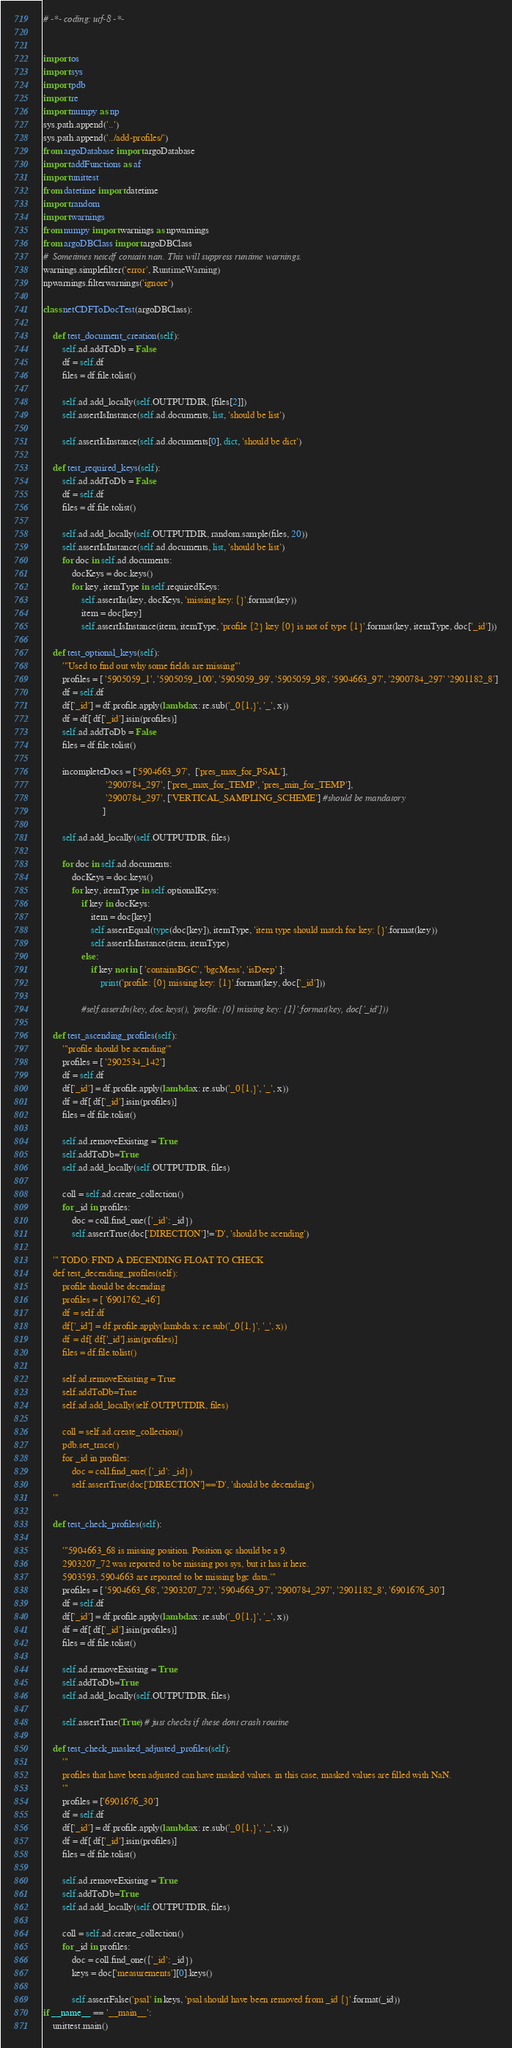Convert code to text. <code><loc_0><loc_0><loc_500><loc_500><_Python_># -*- coding: utf-8 -*-


import os
import sys
import pdb
import re
import numpy as np
sys.path.append('..')
sys.path.append('../add-profiles/')
from argoDatabase import argoDatabase
import addFunctions as af
import unittest
from datetime import datetime
import random
import warnings
from numpy import warnings as npwarnings
from argoDBClass import argoDBClass
#  Sometimes netcdf contain nan. This will suppress runtime warnings.
warnings.simplefilter('error', RuntimeWarning)
npwarnings.filterwarnings('ignore')

class netCDFToDocTest(argoDBClass):
    
    def test_document_creation(self):
        self.ad.addToDb = False
        df = self.df
        files = df.file.tolist()

        self.ad.add_locally(self.OUTPUTDIR, [files[2]])
        self.assertIsInstance(self.ad.documents, list, 'should be list')

        self.assertIsInstance(self.ad.documents[0], dict, 'should be dict')
        
    def test_required_keys(self):
        self.ad.addToDb = False
        df = self.df
        files = df.file.tolist()

        self.ad.add_locally(self.OUTPUTDIR, random.sample(files, 20))
        self.assertIsInstance(self.ad.documents, list, 'should be list')
        for doc in self.ad.documents:
            docKeys = doc.keys()
            for key, itemType in self.requiredKeys:
                self.assertIn(key, docKeys, 'missing key: {}'.format(key))
                item = doc[key]
                self.assertIsInstance(item, itemType, 'profile {2} key {0} is not of type {1}'.format(key, itemType, doc['_id']))

    def test_optional_keys(self):
        '''Used to find out why some fields are missing'''
        profiles = [ '5905059_1', '5905059_100', '5905059_99', '5905059_98', '5904663_97', '2900784_297' '2901182_8']
        df = self.df
        df['_id'] = df.profile.apply(lambda x: re.sub('_0{1,}', '_', x))
        df = df[ df['_id'].isin(profiles)]
        self.ad.addToDb = False
        files = df.file.tolist()
        
        incompleteDocs = ['5904663_97',  ['pres_max_for_PSAL'],
                          '2900784_297', ['pres_max_for_TEMP', 'pres_min_for_TEMP'],
                          '2900784_297', ['VERTICAL_SAMPLING_SCHEME'] #should be mandatory
                         ]
        
        self.ad.add_locally(self.OUTPUTDIR, files)

        for doc in self.ad.documents:
            docKeys = doc.keys()
            for key, itemType in self.optionalKeys:
                if key in docKeys:
                    item = doc[key]
                    self.assertEqual(type(doc[key]), itemType, 'item type should match for key: {}'.format(key))
                    self.assertIsInstance(item, itemType)
                else:
                    if key not in [ 'containsBGC', 'bgcMeas', 'isDeep' ]:
                        print('profile: {0} missing key: {1}'.format(key, doc['_id']))

                #self.assertIn(key, doc.keys(), 'profile: {0} missing key: {1}'.format(key, doc['_id']))

    def test_ascending_profiles(self):
        '''profile should be acending'''
        profiles = [ '2902534_142']
        df = self.df
        df['_id'] = df.profile.apply(lambda x: re.sub('_0{1,}', '_', x))
        df = df[ df['_id'].isin(profiles)]
        files = df.file.tolist()
        
        self.ad.removeExisting = True
        self.addToDb=True
        self.ad.add_locally(self.OUTPUTDIR, files)

        coll = self.ad.create_collection()
        for _id in profiles:
            doc = coll.find_one({'_id': _id})
            self.assertTrue(doc['DIRECTION']!='D', 'should be acending')
            
    ''' TODO: FIND A DECENDING FLOAT TO CHECK
    def test_decending_profiles(self):
        profile should be decending
        profiles = [ '6901762_46']
        df = self.df
        df['_id'] = df.profile.apply(lambda x: re.sub('_0{1,}', '_', x))
        df = df[ df['_id'].isin(profiles)]
        files = df.file.tolist()
        
        self.ad.removeExisting = True
        self.addToDb=True
        self.ad.add_locally(self.OUTPUTDIR, files)

        coll = self.ad.create_collection()
        pdb.set_trace()
        for _id in profiles:
            doc = coll.find_one({'_id': _id})
            self.assertTrue(doc['DIRECTION']=='D', 'should be decending')
    '''

    def test_check_profiles(self):
        
        '''5904663_68 is missing position. Position qc should be a 9.
        2903207_72 was reported to be missing pos sys, but it has it here.
        5903593, 5904663 are reported to be missing bgc data.'''
        profiles = [ '5904663_68', '2903207_72', '5904663_97', '2900784_297', '2901182_8', '6901676_30']
        df = self.df
        df['_id'] = df.profile.apply(lambda x: re.sub('_0{1,}', '_', x))
        df = df[ df['_id'].isin(profiles)]
        files = df.file.tolist()
        
        self.ad.removeExisting = True
        self.addToDb=True
        self.ad.add_locally(self.OUTPUTDIR, files)

        self.assertTrue(True) # just checks if these dont crash routine

    def test_check_masked_adjusted_profiles(self):
        '''
        profiles that have been adjusted can have masked values. in this case, masked values are filled with NaN.
        '''
        profiles = ['6901676_30']
        df = self.df
        df['_id'] = df.profile.apply(lambda x: re.sub('_0{1,}', '_', x))
        df = df[ df['_id'].isin(profiles)]
        files = df.file.tolist()
        
        self.ad.removeExisting = True
        self.addToDb=True
        self.ad.add_locally(self.OUTPUTDIR, files)

        coll = self.ad.create_collection()
        for _id in profiles:
            doc = coll.find_one({'_id': _id})
            keys = doc['measurements'][0].keys()
            
            self.assertFalse('psal' in keys, 'psal should have been removed from _id {}'.format(_id))
if __name__ == '__main__':
    unittest.main()
</code> 